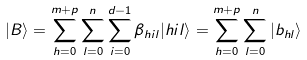Convert formula to latex. <formula><loc_0><loc_0><loc_500><loc_500>| B \rangle = \sum _ { h = 0 } ^ { m + p } \sum _ { l = 0 } ^ { n } \sum _ { i = 0 } ^ { d - 1 } \beta _ { h i l } | h i l \rangle = \sum _ { h = 0 } ^ { m + p } \sum _ { l = 0 } ^ { n } | b _ { h l } \rangle</formula> 